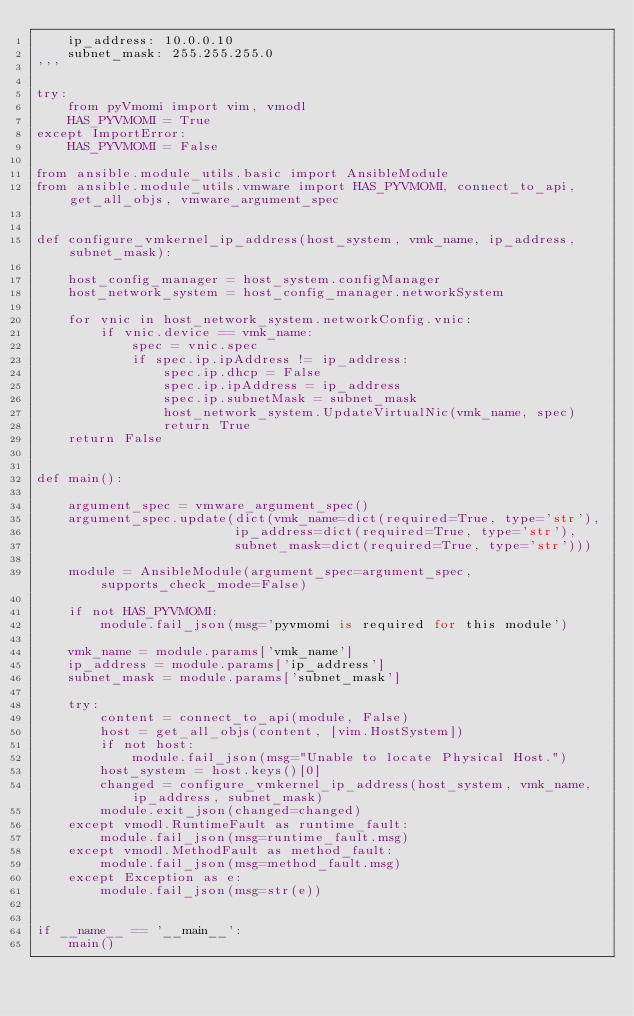Convert code to text. <code><loc_0><loc_0><loc_500><loc_500><_Python_>    ip_address: 10.0.0.10
    subnet_mask: 255.255.255.0
'''

try:
    from pyVmomi import vim, vmodl
    HAS_PYVMOMI = True
except ImportError:
    HAS_PYVMOMI = False

from ansible.module_utils.basic import AnsibleModule
from ansible.module_utils.vmware import HAS_PYVMOMI, connect_to_api, get_all_objs, vmware_argument_spec


def configure_vmkernel_ip_address(host_system, vmk_name, ip_address, subnet_mask):

    host_config_manager = host_system.configManager
    host_network_system = host_config_manager.networkSystem

    for vnic in host_network_system.networkConfig.vnic:
        if vnic.device == vmk_name:
            spec = vnic.spec
            if spec.ip.ipAddress != ip_address:
                spec.ip.dhcp = False
                spec.ip.ipAddress = ip_address
                spec.ip.subnetMask = subnet_mask
                host_network_system.UpdateVirtualNic(vmk_name, spec)
                return True
    return False


def main():

    argument_spec = vmware_argument_spec()
    argument_spec.update(dict(vmk_name=dict(required=True, type='str'),
                         ip_address=dict(required=True, type='str'),
                         subnet_mask=dict(required=True, type='str')))

    module = AnsibleModule(argument_spec=argument_spec, supports_check_mode=False)

    if not HAS_PYVMOMI:
        module.fail_json(msg='pyvmomi is required for this module')

    vmk_name = module.params['vmk_name']
    ip_address = module.params['ip_address']
    subnet_mask = module.params['subnet_mask']

    try:
        content = connect_to_api(module, False)
        host = get_all_objs(content, [vim.HostSystem])
        if not host:
            module.fail_json(msg="Unable to locate Physical Host.")
        host_system = host.keys()[0]
        changed = configure_vmkernel_ip_address(host_system, vmk_name, ip_address, subnet_mask)
        module.exit_json(changed=changed)
    except vmodl.RuntimeFault as runtime_fault:
        module.fail_json(msg=runtime_fault.msg)
    except vmodl.MethodFault as method_fault:
        module.fail_json(msg=method_fault.msg)
    except Exception as e:
        module.fail_json(msg=str(e))


if __name__ == '__main__':
    main()
</code> 